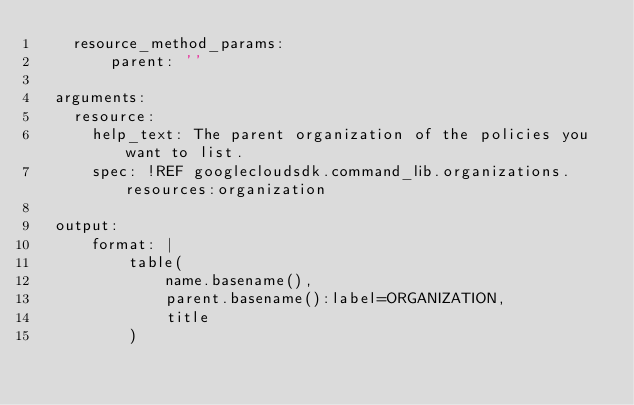Convert code to text. <code><loc_0><loc_0><loc_500><loc_500><_YAML_>    resource_method_params:
        parent: ''

  arguments:
    resource:
      help_text: The parent organization of the policies you want to list.
      spec: !REF googlecloudsdk.command_lib.organizations.resources:organization

  output:
      format: |
          table(
              name.basename(),
              parent.basename():label=ORGANIZATION,
              title
          )
</code> 